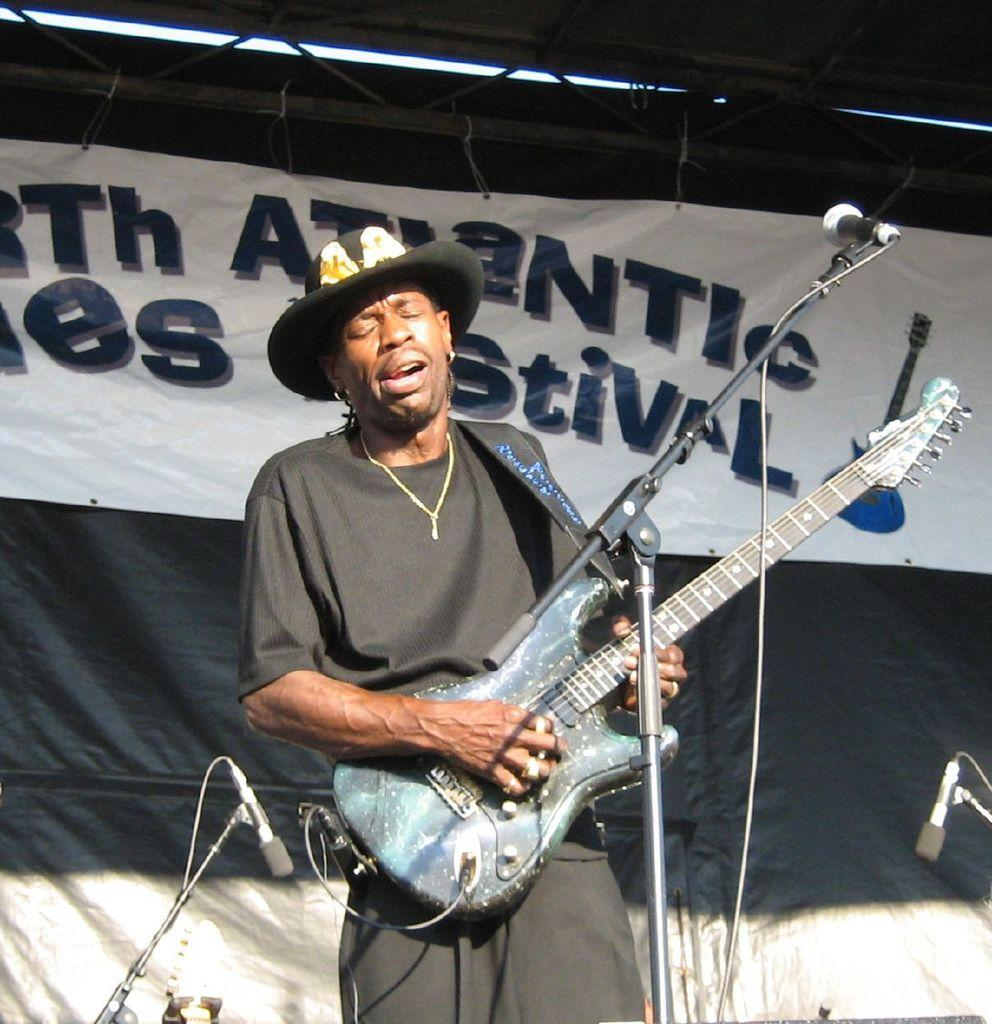What is the man in the image holding? The man is holding a guitar. What is the man positioned in front of in the image? The man is in front of a mic. Are there any other mics visible in the image? Yes, there are two additional mics in the background. What can be seen in the background of the image? There is a banner in the background. How many horses are visible in the image? There are no horses present in the image. Is there a woman in the image? The provided facts do not mention a woman, so we cannot determine if there is one in the image. 